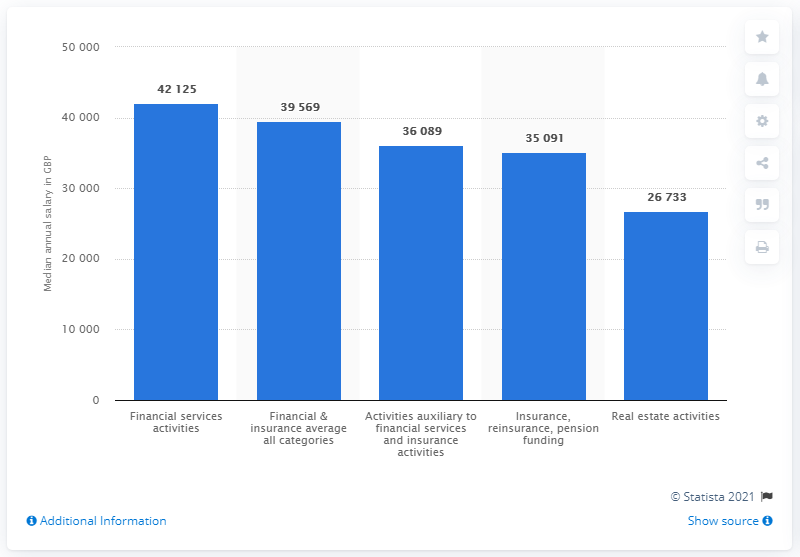Highlight a few significant elements in this photo. The median annual gross salary in the financial services activities sector was 42,125 in 2020. The lowest annual gross salary for real estate services was 26,733. 